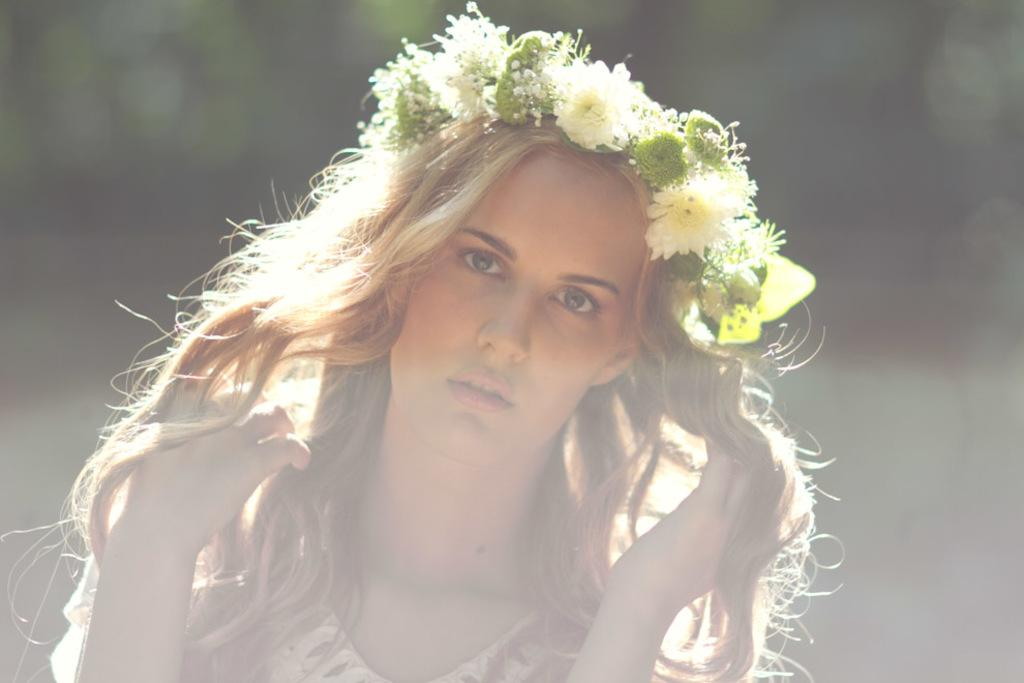Who is the main subject in the image? There is a girl in the image. Where is the girl located in the image? The girl is in the center of the image. What is the girl wearing in her hair? The girl is wearing a flowers hair band. How much zinc does the girl's hair band contain in the image? There is no information about the zinc content of the girl's hair band in the image. 